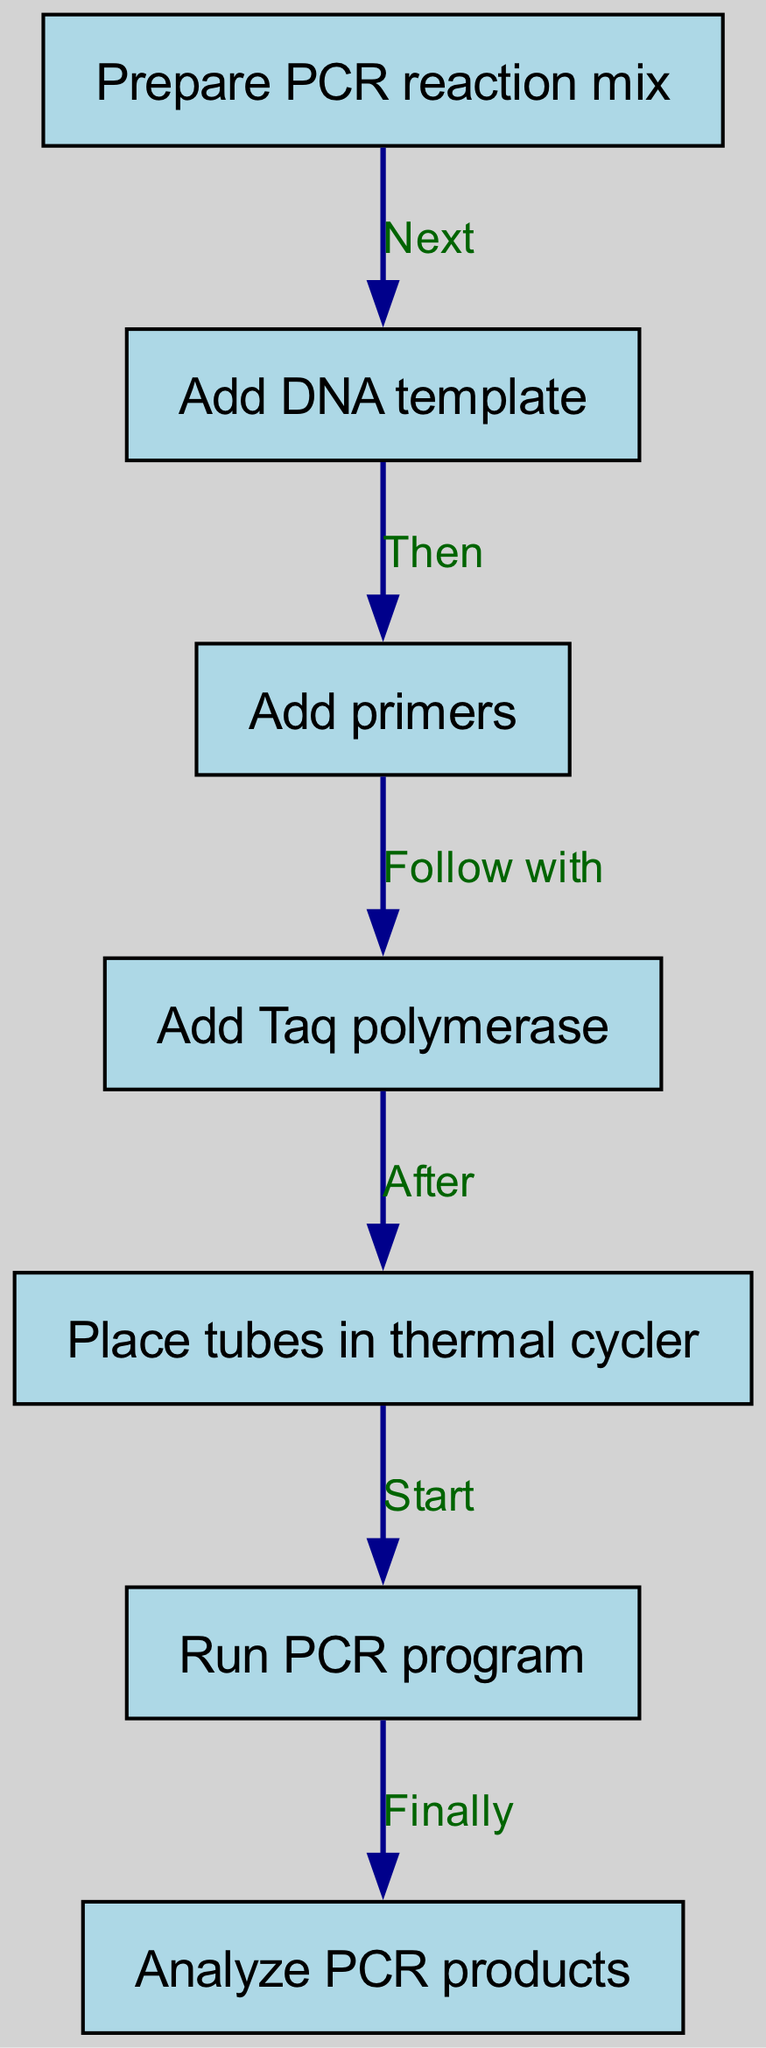What is the first step in the PCR experiment? The first step is represented by the first node in the diagram, which states "Prepare PCR reaction mix." This establishes the starting point of the flowchart and indicates what needs to be done initially.
Answer: Prepare PCR reaction mix How many nodes are in the flowchart? The flowchart includes seven distinct nodes, each representing a specific step in the PCR process. Counting each of the individual steps gives a total of seven nodes.
Answer: 7 What is the step that follows "Add primers"? Moving from the node "Add primers," the next step is indicated in the diagram as "Add Taq polymerase," which is marked as the subsequent action after adding primers.
Answer: Add Taq polymerase What is the last action in the PCR process? The last action is represented by the final node in the flowchart, where it states "Analyze PCR products." This signifies the conclusion of the PCR process and the step that follows the PCR run.
Answer: Analyze PCR products Which step comes before "Place tubes in thermal cycler"? Looking at the flowchart, the step immediately preceding "Place tubes in thermal cycler" is "Add Taq polymerase," indicating that this action must be performed before placing the tubes into the thermal cycler.
Answer: Add Taq polymerase If you follow the chart from "Run PCR program," which step comes directly after? After reaching the node "Run PCR program," the next step is clearly indicated by the arrow pointing to "Analyze PCR products." Following the logical sequence results in this conclusion.
Answer: Analyze PCR products How many edges connect the nodes? The diagram shows a total of six edges, each representing a directional connection or instruction from one step to another in the PCR process, linking all the nodes together.
Answer: 6 What is the relationship between "Add DNA template" and "Add primers"? The connection between these two nodes is sequential; "Add DNA template" leads directly to "Add primers," indicating that the addition of primers follows the template addition in the process.
Answer: Then What is the instruction that bridges "Prepare PCR reaction mix" and "Add DNA template"? The instruction that connects these two nodes is specified as "Next," which indicates that the action of adding the DNA template comes directly after the preparation of the PCR reaction mix.
Answer: Next 